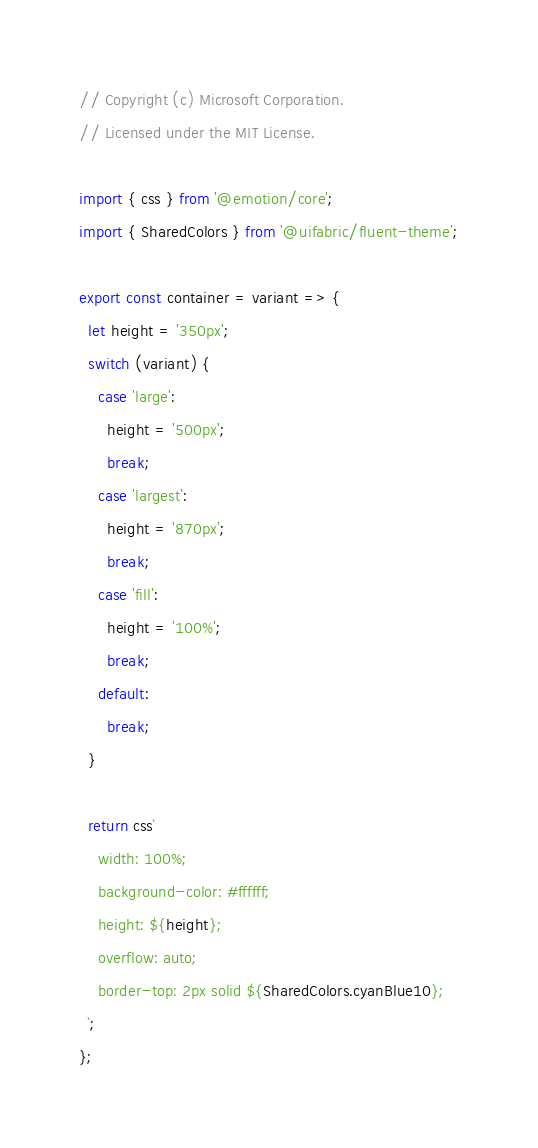Convert code to text. <code><loc_0><loc_0><loc_500><loc_500><_JavaScript_>// Copyright (c) Microsoft Corporation.
// Licensed under the MIT License.

import { css } from '@emotion/core';
import { SharedColors } from '@uifabric/fluent-theme';

export const container = variant => {
  let height = '350px';
  switch (variant) {
    case 'large':
      height = '500px';
      break;
    case 'largest':
      height = '870px';
      break;
    case 'fill':
      height = '100%';
      break;
    default:
      break;
  }

  return css`
    width: 100%;
    background-color: #ffffff;
    height: ${height};
    overflow: auto;
    border-top: 2px solid ${SharedColors.cyanBlue10};
  `;
};
</code> 